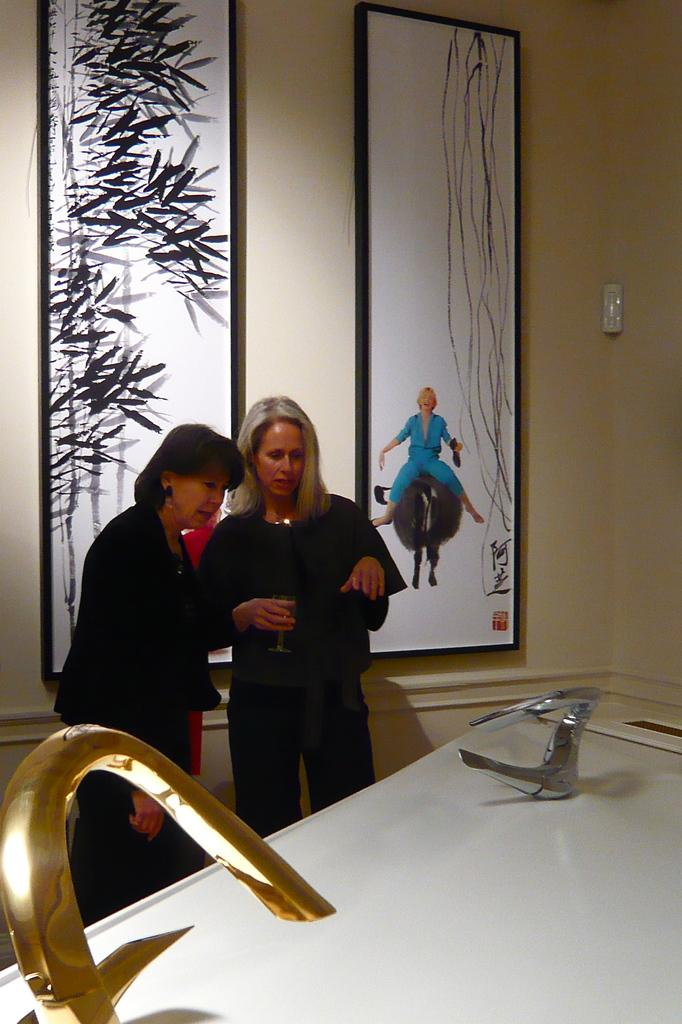How many people are in the image? There are two ladies in the image. What is one of the ladies holding? One lady is holding a glass. What can be seen in the background of the image? There is a wall with photo frames in the background. What is present on a platform in the image? There are tabs on a platform in the image. What type of tiger can be seen in the image? There is no tiger present in the image. What things are being processed in the image? The image does not depict any process or things being processed. 